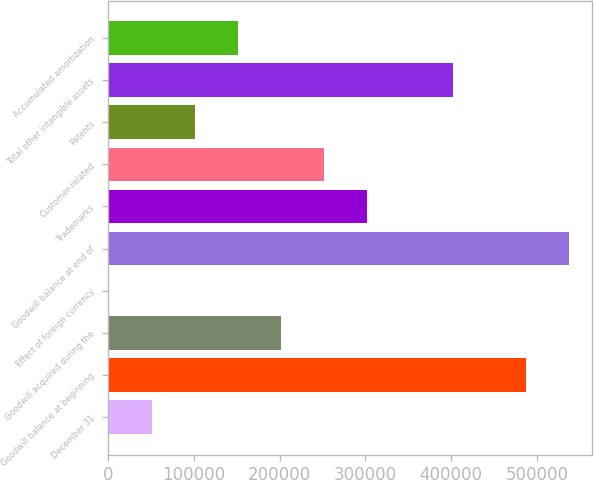Convert chart to OTSL. <chart><loc_0><loc_0><loc_500><loc_500><bar_chart><fcel>December 31<fcel>Goodwill balance at beginning<fcel>Goodwill acquired during the<fcel>Effect of foreign currency<fcel>Goodwill balance at end of<fcel>Trademarks<fcel>Customer-related<fcel>Patents<fcel>Total other intangible assets<fcel>Accumulated amortization<nl><fcel>51055.9<fcel>487338<fcel>201356<fcel>956<fcel>537438<fcel>301555<fcel>251456<fcel>101156<fcel>401755<fcel>151256<nl></chart> 